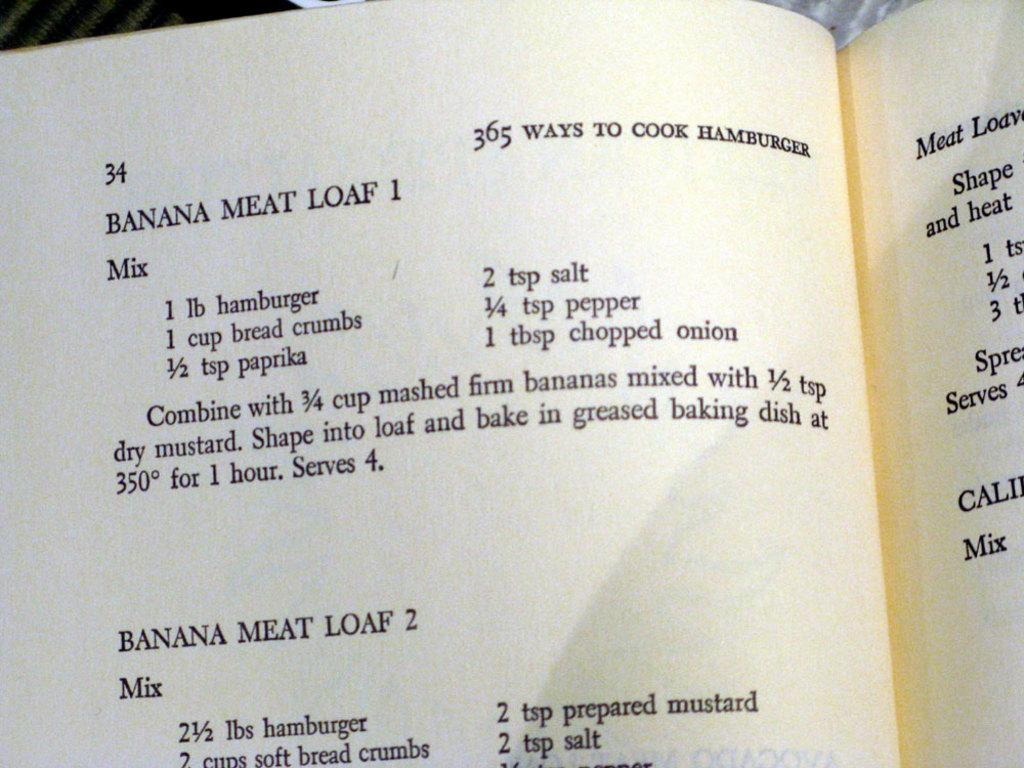<image>
Describe the image concisely. On page 34 of this cookbook is a recipe for banana meat loaf. 